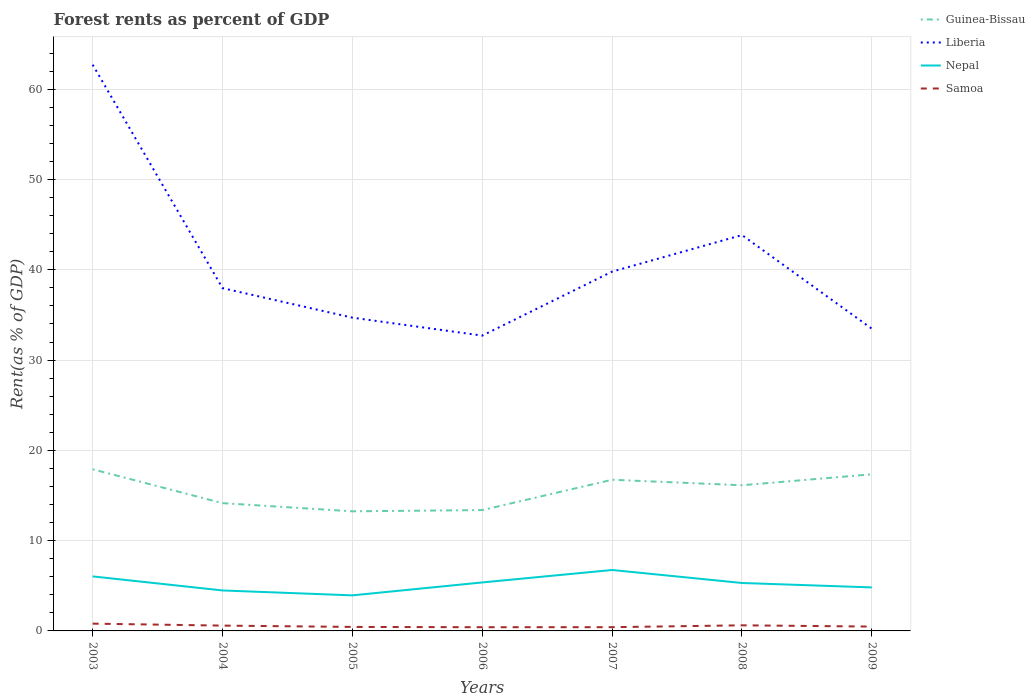Does the line corresponding to Guinea-Bissau intersect with the line corresponding to Liberia?
Provide a short and direct response. No. Is the number of lines equal to the number of legend labels?
Your answer should be very brief. Yes. Across all years, what is the maximum forest rent in Liberia?
Offer a very short reply. 32.71. In which year was the forest rent in Nepal maximum?
Keep it short and to the point. 2005. What is the total forest rent in Liberia in the graph?
Your answer should be very brief. -4.05. What is the difference between the highest and the second highest forest rent in Guinea-Bissau?
Provide a succinct answer. 4.66. What is the difference between the highest and the lowest forest rent in Samoa?
Ensure brevity in your answer.  3. How many lines are there?
Your answer should be compact. 4. How many years are there in the graph?
Your answer should be very brief. 7. Does the graph contain grids?
Provide a succinct answer. Yes. How many legend labels are there?
Provide a succinct answer. 4. How are the legend labels stacked?
Keep it short and to the point. Vertical. What is the title of the graph?
Offer a terse response. Forest rents as percent of GDP. What is the label or title of the X-axis?
Provide a succinct answer. Years. What is the label or title of the Y-axis?
Your answer should be very brief. Rent(as % of GDP). What is the Rent(as % of GDP) in Guinea-Bissau in 2003?
Provide a succinct answer. 17.9. What is the Rent(as % of GDP) of Liberia in 2003?
Provide a succinct answer. 62.72. What is the Rent(as % of GDP) of Nepal in 2003?
Your response must be concise. 6.04. What is the Rent(as % of GDP) in Samoa in 2003?
Keep it short and to the point. 0.81. What is the Rent(as % of GDP) in Guinea-Bissau in 2004?
Offer a terse response. 14.15. What is the Rent(as % of GDP) in Liberia in 2004?
Provide a succinct answer. 37.97. What is the Rent(as % of GDP) of Nepal in 2004?
Provide a short and direct response. 4.48. What is the Rent(as % of GDP) of Samoa in 2004?
Your answer should be very brief. 0.59. What is the Rent(as % of GDP) in Guinea-Bissau in 2005?
Provide a short and direct response. 13.25. What is the Rent(as % of GDP) of Liberia in 2005?
Make the answer very short. 34.7. What is the Rent(as % of GDP) in Nepal in 2005?
Ensure brevity in your answer.  3.94. What is the Rent(as % of GDP) in Samoa in 2005?
Provide a short and direct response. 0.44. What is the Rent(as % of GDP) in Guinea-Bissau in 2006?
Make the answer very short. 13.39. What is the Rent(as % of GDP) of Liberia in 2006?
Your answer should be compact. 32.71. What is the Rent(as % of GDP) of Nepal in 2006?
Give a very brief answer. 5.37. What is the Rent(as % of GDP) of Samoa in 2006?
Offer a very short reply. 0.41. What is the Rent(as % of GDP) of Guinea-Bissau in 2007?
Offer a terse response. 16.74. What is the Rent(as % of GDP) in Liberia in 2007?
Offer a very short reply. 39.8. What is the Rent(as % of GDP) of Nepal in 2007?
Your answer should be very brief. 6.75. What is the Rent(as % of GDP) of Samoa in 2007?
Your response must be concise. 0.41. What is the Rent(as % of GDP) in Guinea-Bissau in 2008?
Provide a succinct answer. 16.13. What is the Rent(as % of GDP) of Liberia in 2008?
Give a very brief answer. 43.85. What is the Rent(as % of GDP) of Nepal in 2008?
Ensure brevity in your answer.  5.31. What is the Rent(as % of GDP) in Samoa in 2008?
Your response must be concise. 0.62. What is the Rent(as % of GDP) of Guinea-Bissau in 2009?
Ensure brevity in your answer.  17.35. What is the Rent(as % of GDP) of Liberia in 2009?
Offer a terse response. 33.48. What is the Rent(as % of GDP) of Nepal in 2009?
Ensure brevity in your answer.  4.82. What is the Rent(as % of GDP) in Samoa in 2009?
Provide a short and direct response. 0.48. Across all years, what is the maximum Rent(as % of GDP) of Guinea-Bissau?
Your answer should be compact. 17.9. Across all years, what is the maximum Rent(as % of GDP) of Liberia?
Ensure brevity in your answer.  62.72. Across all years, what is the maximum Rent(as % of GDP) of Nepal?
Give a very brief answer. 6.75. Across all years, what is the maximum Rent(as % of GDP) in Samoa?
Your response must be concise. 0.81. Across all years, what is the minimum Rent(as % of GDP) of Guinea-Bissau?
Offer a very short reply. 13.25. Across all years, what is the minimum Rent(as % of GDP) of Liberia?
Offer a terse response. 32.71. Across all years, what is the minimum Rent(as % of GDP) in Nepal?
Make the answer very short. 3.94. Across all years, what is the minimum Rent(as % of GDP) in Samoa?
Offer a very short reply. 0.41. What is the total Rent(as % of GDP) in Guinea-Bissau in the graph?
Your answer should be very brief. 108.92. What is the total Rent(as % of GDP) in Liberia in the graph?
Your response must be concise. 285.21. What is the total Rent(as % of GDP) in Nepal in the graph?
Offer a terse response. 36.71. What is the total Rent(as % of GDP) of Samoa in the graph?
Offer a terse response. 3.76. What is the difference between the Rent(as % of GDP) of Guinea-Bissau in 2003 and that in 2004?
Provide a short and direct response. 3.75. What is the difference between the Rent(as % of GDP) of Liberia in 2003 and that in 2004?
Provide a short and direct response. 24.75. What is the difference between the Rent(as % of GDP) of Nepal in 2003 and that in 2004?
Make the answer very short. 1.56. What is the difference between the Rent(as % of GDP) in Samoa in 2003 and that in 2004?
Keep it short and to the point. 0.22. What is the difference between the Rent(as % of GDP) in Guinea-Bissau in 2003 and that in 2005?
Your answer should be very brief. 4.66. What is the difference between the Rent(as % of GDP) of Liberia in 2003 and that in 2005?
Keep it short and to the point. 28.02. What is the difference between the Rent(as % of GDP) in Nepal in 2003 and that in 2005?
Provide a succinct answer. 2.1. What is the difference between the Rent(as % of GDP) in Samoa in 2003 and that in 2005?
Give a very brief answer. 0.36. What is the difference between the Rent(as % of GDP) of Guinea-Bissau in 2003 and that in 2006?
Provide a succinct answer. 4.52. What is the difference between the Rent(as % of GDP) of Liberia in 2003 and that in 2006?
Offer a terse response. 30.01. What is the difference between the Rent(as % of GDP) of Nepal in 2003 and that in 2006?
Give a very brief answer. 0.67. What is the difference between the Rent(as % of GDP) in Samoa in 2003 and that in 2006?
Make the answer very short. 0.4. What is the difference between the Rent(as % of GDP) of Guinea-Bissau in 2003 and that in 2007?
Make the answer very short. 1.16. What is the difference between the Rent(as % of GDP) of Liberia in 2003 and that in 2007?
Ensure brevity in your answer.  22.92. What is the difference between the Rent(as % of GDP) of Nepal in 2003 and that in 2007?
Offer a terse response. -0.71. What is the difference between the Rent(as % of GDP) in Samoa in 2003 and that in 2007?
Give a very brief answer. 0.39. What is the difference between the Rent(as % of GDP) in Guinea-Bissau in 2003 and that in 2008?
Offer a terse response. 1.77. What is the difference between the Rent(as % of GDP) in Liberia in 2003 and that in 2008?
Offer a terse response. 18.87. What is the difference between the Rent(as % of GDP) in Nepal in 2003 and that in 2008?
Give a very brief answer. 0.73. What is the difference between the Rent(as % of GDP) of Samoa in 2003 and that in 2008?
Your answer should be very brief. 0.19. What is the difference between the Rent(as % of GDP) of Guinea-Bissau in 2003 and that in 2009?
Provide a short and direct response. 0.56. What is the difference between the Rent(as % of GDP) of Liberia in 2003 and that in 2009?
Offer a terse response. 29.24. What is the difference between the Rent(as % of GDP) of Nepal in 2003 and that in 2009?
Your response must be concise. 1.22. What is the difference between the Rent(as % of GDP) in Samoa in 2003 and that in 2009?
Keep it short and to the point. 0.33. What is the difference between the Rent(as % of GDP) in Guinea-Bissau in 2004 and that in 2005?
Offer a very short reply. 0.9. What is the difference between the Rent(as % of GDP) in Liberia in 2004 and that in 2005?
Provide a short and direct response. 3.27. What is the difference between the Rent(as % of GDP) in Nepal in 2004 and that in 2005?
Provide a short and direct response. 0.54. What is the difference between the Rent(as % of GDP) of Samoa in 2004 and that in 2005?
Offer a very short reply. 0.15. What is the difference between the Rent(as % of GDP) in Guinea-Bissau in 2004 and that in 2006?
Offer a terse response. 0.77. What is the difference between the Rent(as % of GDP) of Liberia in 2004 and that in 2006?
Your response must be concise. 5.26. What is the difference between the Rent(as % of GDP) of Nepal in 2004 and that in 2006?
Keep it short and to the point. -0.89. What is the difference between the Rent(as % of GDP) in Samoa in 2004 and that in 2006?
Offer a very short reply. 0.18. What is the difference between the Rent(as % of GDP) in Guinea-Bissau in 2004 and that in 2007?
Your answer should be very brief. -2.59. What is the difference between the Rent(as % of GDP) of Liberia in 2004 and that in 2007?
Provide a succinct answer. -1.83. What is the difference between the Rent(as % of GDP) in Nepal in 2004 and that in 2007?
Ensure brevity in your answer.  -2.27. What is the difference between the Rent(as % of GDP) of Samoa in 2004 and that in 2007?
Provide a succinct answer. 0.17. What is the difference between the Rent(as % of GDP) in Guinea-Bissau in 2004 and that in 2008?
Your answer should be compact. -1.98. What is the difference between the Rent(as % of GDP) of Liberia in 2004 and that in 2008?
Ensure brevity in your answer.  -5.88. What is the difference between the Rent(as % of GDP) of Nepal in 2004 and that in 2008?
Your answer should be very brief. -0.83. What is the difference between the Rent(as % of GDP) in Samoa in 2004 and that in 2008?
Give a very brief answer. -0.03. What is the difference between the Rent(as % of GDP) in Guinea-Bissau in 2004 and that in 2009?
Keep it short and to the point. -3.2. What is the difference between the Rent(as % of GDP) of Liberia in 2004 and that in 2009?
Offer a terse response. 4.49. What is the difference between the Rent(as % of GDP) in Nepal in 2004 and that in 2009?
Ensure brevity in your answer.  -0.34. What is the difference between the Rent(as % of GDP) of Samoa in 2004 and that in 2009?
Give a very brief answer. 0.11. What is the difference between the Rent(as % of GDP) of Guinea-Bissau in 2005 and that in 2006?
Offer a terse response. -0.14. What is the difference between the Rent(as % of GDP) in Liberia in 2005 and that in 2006?
Your response must be concise. 1.99. What is the difference between the Rent(as % of GDP) of Nepal in 2005 and that in 2006?
Provide a short and direct response. -1.43. What is the difference between the Rent(as % of GDP) in Samoa in 2005 and that in 2006?
Make the answer very short. 0.03. What is the difference between the Rent(as % of GDP) of Guinea-Bissau in 2005 and that in 2007?
Your answer should be compact. -3.5. What is the difference between the Rent(as % of GDP) in Liberia in 2005 and that in 2007?
Your answer should be very brief. -5.1. What is the difference between the Rent(as % of GDP) in Nepal in 2005 and that in 2007?
Provide a short and direct response. -2.81. What is the difference between the Rent(as % of GDP) of Samoa in 2005 and that in 2007?
Your answer should be very brief. 0.03. What is the difference between the Rent(as % of GDP) in Guinea-Bissau in 2005 and that in 2008?
Ensure brevity in your answer.  -2.89. What is the difference between the Rent(as % of GDP) in Liberia in 2005 and that in 2008?
Give a very brief answer. -9.15. What is the difference between the Rent(as % of GDP) of Nepal in 2005 and that in 2008?
Your response must be concise. -1.37. What is the difference between the Rent(as % of GDP) in Samoa in 2005 and that in 2008?
Ensure brevity in your answer.  -0.18. What is the difference between the Rent(as % of GDP) of Guinea-Bissau in 2005 and that in 2009?
Provide a short and direct response. -4.1. What is the difference between the Rent(as % of GDP) in Liberia in 2005 and that in 2009?
Make the answer very short. 1.22. What is the difference between the Rent(as % of GDP) of Nepal in 2005 and that in 2009?
Offer a terse response. -0.88. What is the difference between the Rent(as % of GDP) of Samoa in 2005 and that in 2009?
Give a very brief answer. -0.04. What is the difference between the Rent(as % of GDP) in Guinea-Bissau in 2006 and that in 2007?
Make the answer very short. -3.36. What is the difference between the Rent(as % of GDP) in Liberia in 2006 and that in 2007?
Ensure brevity in your answer.  -7.09. What is the difference between the Rent(as % of GDP) of Nepal in 2006 and that in 2007?
Keep it short and to the point. -1.38. What is the difference between the Rent(as % of GDP) of Samoa in 2006 and that in 2007?
Give a very brief answer. -0. What is the difference between the Rent(as % of GDP) of Guinea-Bissau in 2006 and that in 2008?
Keep it short and to the point. -2.75. What is the difference between the Rent(as % of GDP) in Liberia in 2006 and that in 2008?
Your answer should be compact. -11.14. What is the difference between the Rent(as % of GDP) of Nepal in 2006 and that in 2008?
Offer a terse response. 0.06. What is the difference between the Rent(as % of GDP) in Samoa in 2006 and that in 2008?
Make the answer very short. -0.21. What is the difference between the Rent(as % of GDP) in Guinea-Bissau in 2006 and that in 2009?
Keep it short and to the point. -3.96. What is the difference between the Rent(as % of GDP) in Liberia in 2006 and that in 2009?
Your answer should be very brief. -0.77. What is the difference between the Rent(as % of GDP) of Nepal in 2006 and that in 2009?
Give a very brief answer. 0.55. What is the difference between the Rent(as % of GDP) in Samoa in 2006 and that in 2009?
Provide a short and direct response. -0.07. What is the difference between the Rent(as % of GDP) in Guinea-Bissau in 2007 and that in 2008?
Keep it short and to the point. 0.61. What is the difference between the Rent(as % of GDP) in Liberia in 2007 and that in 2008?
Make the answer very short. -4.05. What is the difference between the Rent(as % of GDP) in Nepal in 2007 and that in 2008?
Give a very brief answer. 1.44. What is the difference between the Rent(as % of GDP) in Samoa in 2007 and that in 2008?
Make the answer very short. -0.21. What is the difference between the Rent(as % of GDP) of Guinea-Bissau in 2007 and that in 2009?
Your answer should be very brief. -0.6. What is the difference between the Rent(as % of GDP) in Liberia in 2007 and that in 2009?
Offer a terse response. 6.32. What is the difference between the Rent(as % of GDP) of Nepal in 2007 and that in 2009?
Offer a terse response. 1.93. What is the difference between the Rent(as % of GDP) of Samoa in 2007 and that in 2009?
Provide a succinct answer. -0.07. What is the difference between the Rent(as % of GDP) in Guinea-Bissau in 2008 and that in 2009?
Offer a terse response. -1.21. What is the difference between the Rent(as % of GDP) in Liberia in 2008 and that in 2009?
Your response must be concise. 10.37. What is the difference between the Rent(as % of GDP) of Nepal in 2008 and that in 2009?
Keep it short and to the point. 0.49. What is the difference between the Rent(as % of GDP) of Samoa in 2008 and that in 2009?
Offer a terse response. 0.14. What is the difference between the Rent(as % of GDP) in Guinea-Bissau in 2003 and the Rent(as % of GDP) in Liberia in 2004?
Offer a terse response. -20.06. What is the difference between the Rent(as % of GDP) in Guinea-Bissau in 2003 and the Rent(as % of GDP) in Nepal in 2004?
Make the answer very short. 13.42. What is the difference between the Rent(as % of GDP) in Guinea-Bissau in 2003 and the Rent(as % of GDP) in Samoa in 2004?
Offer a very short reply. 17.32. What is the difference between the Rent(as % of GDP) of Liberia in 2003 and the Rent(as % of GDP) of Nepal in 2004?
Your answer should be compact. 58.23. What is the difference between the Rent(as % of GDP) of Liberia in 2003 and the Rent(as % of GDP) of Samoa in 2004?
Make the answer very short. 62.13. What is the difference between the Rent(as % of GDP) in Nepal in 2003 and the Rent(as % of GDP) in Samoa in 2004?
Offer a very short reply. 5.45. What is the difference between the Rent(as % of GDP) in Guinea-Bissau in 2003 and the Rent(as % of GDP) in Liberia in 2005?
Provide a succinct answer. -16.8. What is the difference between the Rent(as % of GDP) in Guinea-Bissau in 2003 and the Rent(as % of GDP) in Nepal in 2005?
Provide a succinct answer. 13.97. What is the difference between the Rent(as % of GDP) in Guinea-Bissau in 2003 and the Rent(as % of GDP) in Samoa in 2005?
Your answer should be compact. 17.46. What is the difference between the Rent(as % of GDP) in Liberia in 2003 and the Rent(as % of GDP) in Nepal in 2005?
Give a very brief answer. 58.78. What is the difference between the Rent(as % of GDP) of Liberia in 2003 and the Rent(as % of GDP) of Samoa in 2005?
Provide a succinct answer. 62.28. What is the difference between the Rent(as % of GDP) in Nepal in 2003 and the Rent(as % of GDP) in Samoa in 2005?
Your answer should be compact. 5.6. What is the difference between the Rent(as % of GDP) of Guinea-Bissau in 2003 and the Rent(as % of GDP) of Liberia in 2006?
Make the answer very short. -14.81. What is the difference between the Rent(as % of GDP) of Guinea-Bissau in 2003 and the Rent(as % of GDP) of Nepal in 2006?
Provide a succinct answer. 12.53. What is the difference between the Rent(as % of GDP) of Guinea-Bissau in 2003 and the Rent(as % of GDP) of Samoa in 2006?
Give a very brief answer. 17.49. What is the difference between the Rent(as % of GDP) of Liberia in 2003 and the Rent(as % of GDP) of Nepal in 2006?
Offer a very short reply. 57.35. What is the difference between the Rent(as % of GDP) of Liberia in 2003 and the Rent(as % of GDP) of Samoa in 2006?
Your answer should be very brief. 62.31. What is the difference between the Rent(as % of GDP) in Nepal in 2003 and the Rent(as % of GDP) in Samoa in 2006?
Ensure brevity in your answer.  5.63. What is the difference between the Rent(as % of GDP) in Guinea-Bissau in 2003 and the Rent(as % of GDP) in Liberia in 2007?
Give a very brief answer. -21.89. What is the difference between the Rent(as % of GDP) of Guinea-Bissau in 2003 and the Rent(as % of GDP) of Nepal in 2007?
Provide a succinct answer. 11.16. What is the difference between the Rent(as % of GDP) of Guinea-Bissau in 2003 and the Rent(as % of GDP) of Samoa in 2007?
Offer a terse response. 17.49. What is the difference between the Rent(as % of GDP) in Liberia in 2003 and the Rent(as % of GDP) in Nepal in 2007?
Offer a terse response. 55.97. What is the difference between the Rent(as % of GDP) in Liberia in 2003 and the Rent(as % of GDP) in Samoa in 2007?
Give a very brief answer. 62.3. What is the difference between the Rent(as % of GDP) of Nepal in 2003 and the Rent(as % of GDP) of Samoa in 2007?
Offer a very short reply. 5.62. What is the difference between the Rent(as % of GDP) in Guinea-Bissau in 2003 and the Rent(as % of GDP) in Liberia in 2008?
Provide a short and direct response. -25.94. What is the difference between the Rent(as % of GDP) in Guinea-Bissau in 2003 and the Rent(as % of GDP) in Nepal in 2008?
Your answer should be compact. 12.59. What is the difference between the Rent(as % of GDP) of Guinea-Bissau in 2003 and the Rent(as % of GDP) of Samoa in 2008?
Provide a short and direct response. 17.28. What is the difference between the Rent(as % of GDP) of Liberia in 2003 and the Rent(as % of GDP) of Nepal in 2008?
Your answer should be very brief. 57.41. What is the difference between the Rent(as % of GDP) in Liberia in 2003 and the Rent(as % of GDP) in Samoa in 2008?
Keep it short and to the point. 62.1. What is the difference between the Rent(as % of GDP) of Nepal in 2003 and the Rent(as % of GDP) of Samoa in 2008?
Your answer should be compact. 5.42. What is the difference between the Rent(as % of GDP) of Guinea-Bissau in 2003 and the Rent(as % of GDP) of Liberia in 2009?
Ensure brevity in your answer.  -15.57. What is the difference between the Rent(as % of GDP) of Guinea-Bissau in 2003 and the Rent(as % of GDP) of Nepal in 2009?
Give a very brief answer. 13.08. What is the difference between the Rent(as % of GDP) of Guinea-Bissau in 2003 and the Rent(as % of GDP) of Samoa in 2009?
Your response must be concise. 17.42. What is the difference between the Rent(as % of GDP) of Liberia in 2003 and the Rent(as % of GDP) of Nepal in 2009?
Your answer should be very brief. 57.9. What is the difference between the Rent(as % of GDP) of Liberia in 2003 and the Rent(as % of GDP) of Samoa in 2009?
Your answer should be very brief. 62.24. What is the difference between the Rent(as % of GDP) of Nepal in 2003 and the Rent(as % of GDP) of Samoa in 2009?
Provide a succinct answer. 5.56. What is the difference between the Rent(as % of GDP) of Guinea-Bissau in 2004 and the Rent(as % of GDP) of Liberia in 2005?
Your answer should be very brief. -20.55. What is the difference between the Rent(as % of GDP) of Guinea-Bissau in 2004 and the Rent(as % of GDP) of Nepal in 2005?
Your answer should be compact. 10.21. What is the difference between the Rent(as % of GDP) in Guinea-Bissau in 2004 and the Rent(as % of GDP) in Samoa in 2005?
Ensure brevity in your answer.  13.71. What is the difference between the Rent(as % of GDP) in Liberia in 2004 and the Rent(as % of GDP) in Nepal in 2005?
Ensure brevity in your answer.  34.03. What is the difference between the Rent(as % of GDP) of Liberia in 2004 and the Rent(as % of GDP) of Samoa in 2005?
Ensure brevity in your answer.  37.52. What is the difference between the Rent(as % of GDP) in Nepal in 2004 and the Rent(as % of GDP) in Samoa in 2005?
Provide a succinct answer. 4.04. What is the difference between the Rent(as % of GDP) in Guinea-Bissau in 2004 and the Rent(as % of GDP) in Liberia in 2006?
Give a very brief answer. -18.56. What is the difference between the Rent(as % of GDP) in Guinea-Bissau in 2004 and the Rent(as % of GDP) in Nepal in 2006?
Offer a terse response. 8.78. What is the difference between the Rent(as % of GDP) of Guinea-Bissau in 2004 and the Rent(as % of GDP) of Samoa in 2006?
Provide a short and direct response. 13.74. What is the difference between the Rent(as % of GDP) in Liberia in 2004 and the Rent(as % of GDP) in Nepal in 2006?
Give a very brief answer. 32.6. What is the difference between the Rent(as % of GDP) in Liberia in 2004 and the Rent(as % of GDP) in Samoa in 2006?
Ensure brevity in your answer.  37.56. What is the difference between the Rent(as % of GDP) in Nepal in 2004 and the Rent(as % of GDP) in Samoa in 2006?
Keep it short and to the point. 4.07. What is the difference between the Rent(as % of GDP) of Guinea-Bissau in 2004 and the Rent(as % of GDP) of Liberia in 2007?
Offer a terse response. -25.65. What is the difference between the Rent(as % of GDP) of Guinea-Bissau in 2004 and the Rent(as % of GDP) of Nepal in 2007?
Your response must be concise. 7.4. What is the difference between the Rent(as % of GDP) of Guinea-Bissau in 2004 and the Rent(as % of GDP) of Samoa in 2007?
Your answer should be very brief. 13.74. What is the difference between the Rent(as % of GDP) in Liberia in 2004 and the Rent(as % of GDP) in Nepal in 2007?
Your answer should be very brief. 31.22. What is the difference between the Rent(as % of GDP) of Liberia in 2004 and the Rent(as % of GDP) of Samoa in 2007?
Offer a very short reply. 37.55. What is the difference between the Rent(as % of GDP) in Nepal in 2004 and the Rent(as % of GDP) in Samoa in 2007?
Your answer should be compact. 4.07. What is the difference between the Rent(as % of GDP) of Guinea-Bissau in 2004 and the Rent(as % of GDP) of Liberia in 2008?
Your answer should be very brief. -29.69. What is the difference between the Rent(as % of GDP) of Guinea-Bissau in 2004 and the Rent(as % of GDP) of Nepal in 2008?
Give a very brief answer. 8.84. What is the difference between the Rent(as % of GDP) in Guinea-Bissau in 2004 and the Rent(as % of GDP) in Samoa in 2008?
Your answer should be compact. 13.53. What is the difference between the Rent(as % of GDP) of Liberia in 2004 and the Rent(as % of GDP) of Nepal in 2008?
Your answer should be very brief. 32.66. What is the difference between the Rent(as % of GDP) in Liberia in 2004 and the Rent(as % of GDP) in Samoa in 2008?
Give a very brief answer. 37.35. What is the difference between the Rent(as % of GDP) of Nepal in 2004 and the Rent(as % of GDP) of Samoa in 2008?
Ensure brevity in your answer.  3.86. What is the difference between the Rent(as % of GDP) of Guinea-Bissau in 2004 and the Rent(as % of GDP) of Liberia in 2009?
Give a very brief answer. -19.32. What is the difference between the Rent(as % of GDP) in Guinea-Bissau in 2004 and the Rent(as % of GDP) in Nepal in 2009?
Offer a terse response. 9.33. What is the difference between the Rent(as % of GDP) in Guinea-Bissau in 2004 and the Rent(as % of GDP) in Samoa in 2009?
Offer a terse response. 13.67. What is the difference between the Rent(as % of GDP) in Liberia in 2004 and the Rent(as % of GDP) in Nepal in 2009?
Offer a very short reply. 33.15. What is the difference between the Rent(as % of GDP) in Liberia in 2004 and the Rent(as % of GDP) in Samoa in 2009?
Provide a succinct answer. 37.49. What is the difference between the Rent(as % of GDP) of Nepal in 2004 and the Rent(as % of GDP) of Samoa in 2009?
Offer a terse response. 4. What is the difference between the Rent(as % of GDP) in Guinea-Bissau in 2005 and the Rent(as % of GDP) in Liberia in 2006?
Your answer should be compact. -19.46. What is the difference between the Rent(as % of GDP) of Guinea-Bissau in 2005 and the Rent(as % of GDP) of Nepal in 2006?
Make the answer very short. 7.88. What is the difference between the Rent(as % of GDP) in Guinea-Bissau in 2005 and the Rent(as % of GDP) in Samoa in 2006?
Ensure brevity in your answer.  12.84. What is the difference between the Rent(as % of GDP) of Liberia in 2005 and the Rent(as % of GDP) of Nepal in 2006?
Your response must be concise. 29.33. What is the difference between the Rent(as % of GDP) of Liberia in 2005 and the Rent(as % of GDP) of Samoa in 2006?
Ensure brevity in your answer.  34.29. What is the difference between the Rent(as % of GDP) in Nepal in 2005 and the Rent(as % of GDP) in Samoa in 2006?
Make the answer very short. 3.53. What is the difference between the Rent(as % of GDP) of Guinea-Bissau in 2005 and the Rent(as % of GDP) of Liberia in 2007?
Provide a succinct answer. -26.55. What is the difference between the Rent(as % of GDP) of Guinea-Bissau in 2005 and the Rent(as % of GDP) of Nepal in 2007?
Give a very brief answer. 6.5. What is the difference between the Rent(as % of GDP) of Guinea-Bissau in 2005 and the Rent(as % of GDP) of Samoa in 2007?
Offer a terse response. 12.83. What is the difference between the Rent(as % of GDP) of Liberia in 2005 and the Rent(as % of GDP) of Nepal in 2007?
Keep it short and to the point. 27.95. What is the difference between the Rent(as % of GDP) in Liberia in 2005 and the Rent(as % of GDP) in Samoa in 2007?
Give a very brief answer. 34.28. What is the difference between the Rent(as % of GDP) in Nepal in 2005 and the Rent(as % of GDP) in Samoa in 2007?
Offer a terse response. 3.52. What is the difference between the Rent(as % of GDP) of Guinea-Bissau in 2005 and the Rent(as % of GDP) of Liberia in 2008?
Provide a succinct answer. -30.6. What is the difference between the Rent(as % of GDP) in Guinea-Bissau in 2005 and the Rent(as % of GDP) in Nepal in 2008?
Give a very brief answer. 7.94. What is the difference between the Rent(as % of GDP) of Guinea-Bissau in 2005 and the Rent(as % of GDP) of Samoa in 2008?
Your answer should be very brief. 12.63. What is the difference between the Rent(as % of GDP) of Liberia in 2005 and the Rent(as % of GDP) of Nepal in 2008?
Make the answer very short. 29.39. What is the difference between the Rent(as % of GDP) of Liberia in 2005 and the Rent(as % of GDP) of Samoa in 2008?
Your response must be concise. 34.08. What is the difference between the Rent(as % of GDP) of Nepal in 2005 and the Rent(as % of GDP) of Samoa in 2008?
Your answer should be very brief. 3.32. What is the difference between the Rent(as % of GDP) of Guinea-Bissau in 2005 and the Rent(as % of GDP) of Liberia in 2009?
Your answer should be compact. -20.23. What is the difference between the Rent(as % of GDP) of Guinea-Bissau in 2005 and the Rent(as % of GDP) of Nepal in 2009?
Keep it short and to the point. 8.43. What is the difference between the Rent(as % of GDP) of Guinea-Bissau in 2005 and the Rent(as % of GDP) of Samoa in 2009?
Give a very brief answer. 12.77. What is the difference between the Rent(as % of GDP) of Liberia in 2005 and the Rent(as % of GDP) of Nepal in 2009?
Provide a succinct answer. 29.88. What is the difference between the Rent(as % of GDP) of Liberia in 2005 and the Rent(as % of GDP) of Samoa in 2009?
Your answer should be compact. 34.22. What is the difference between the Rent(as % of GDP) of Nepal in 2005 and the Rent(as % of GDP) of Samoa in 2009?
Ensure brevity in your answer.  3.46. What is the difference between the Rent(as % of GDP) in Guinea-Bissau in 2006 and the Rent(as % of GDP) in Liberia in 2007?
Offer a very short reply. -26.41. What is the difference between the Rent(as % of GDP) of Guinea-Bissau in 2006 and the Rent(as % of GDP) of Nepal in 2007?
Give a very brief answer. 6.64. What is the difference between the Rent(as % of GDP) in Guinea-Bissau in 2006 and the Rent(as % of GDP) in Samoa in 2007?
Offer a very short reply. 12.97. What is the difference between the Rent(as % of GDP) in Liberia in 2006 and the Rent(as % of GDP) in Nepal in 2007?
Offer a very short reply. 25.96. What is the difference between the Rent(as % of GDP) of Liberia in 2006 and the Rent(as % of GDP) of Samoa in 2007?
Give a very brief answer. 32.3. What is the difference between the Rent(as % of GDP) of Nepal in 2006 and the Rent(as % of GDP) of Samoa in 2007?
Your answer should be very brief. 4.96. What is the difference between the Rent(as % of GDP) in Guinea-Bissau in 2006 and the Rent(as % of GDP) in Liberia in 2008?
Provide a short and direct response. -30.46. What is the difference between the Rent(as % of GDP) in Guinea-Bissau in 2006 and the Rent(as % of GDP) in Nepal in 2008?
Keep it short and to the point. 8.08. What is the difference between the Rent(as % of GDP) in Guinea-Bissau in 2006 and the Rent(as % of GDP) in Samoa in 2008?
Your response must be concise. 12.77. What is the difference between the Rent(as % of GDP) of Liberia in 2006 and the Rent(as % of GDP) of Nepal in 2008?
Give a very brief answer. 27.4. What is the difference between the Rent(as % of GDP) in Liberia in 2006 and the Rent(as % of GDP) in Samoa in 2008?
Offer a terse response. 32.09. What is the difference between the Rent(as % of GDP) in Nepal in 2006 and the Rent(as % of GDP) in Samoa in 2008?
Ensure brevity in your answer.  4.75. What is the difference between the Rent(as % of GDP) in Guinea-Bissau in 2006 and the Rent(as % of GDP) in Liberia in 2009?
Give a very brief answer. -20.09. What is the difference between the Rent(as % of GDP) in Guinea-Bissau in 2006 and the Rent(as % of GDP) in Nepal in 2009?
Offer a very short reply. 8.56. What is the difference between the Rent(as % of GDP) in Guinea-Bissau in 2006 and the Rent(as % of GDP) in Samoa in 2009?
Provide a short and direct response. 12.9. What is the difference between the Rent(as % of GDP) of Liberia in 2006 and the Rent(as % of GDP) of Nepal in 2009?
Keep it short and to the point. 27.89. What is the difference between the Rent(as % of GDP) in Liberia in 2006 and the Rent(as % of GDP) in Samoa in 2009?
Give a very brief answer. 32.23. What is the difference between the Rent(as % of GDP) in Nepal in 2006 and the Rent(as % of GDP) in Samoa in 2009?
Offer a very short reply. 4.89. What is the difference between the Rent(as % of GDP) in Guinea-Bissau in 2007 and the Rent(as % of GDP) in Liberia in 2008?
Your response must be concise. -27.1. What is the difference between the Rent(as % of GDP) in Guinea-Bissau in 2007 and the Rent(as % of GDP) in Nepal in 2008?
Ensure brevity in your answer.  11.43. What is the difference between the Rent(as % of GDP) of Guinea-Bissau in 2007 and the Rent(as % of GDP) of Samoa in 2008?
Offer a very short reply. 16.12. What is the difference between the Rent(as % of GDP) in Liberia in 2007 and the Rent(as % of GDP) in Nepal in 2008?
Your answer should be very brief. 34.49. What is the difference between the Rent(as % of GDP) in Liberia in 2007 and the Rent(as % of GDP) in Samoa in 2008?
Keep it short and to the point. 39.18. What is the difference between the Rent(as % of GDP) in Nepal in 2007 and the Rent(as % of GDP) in Samoa in 2008?
Offer a terse response. 6.13. What is the difference between the Rent(as % of GDP) in Guinea-Bissau in 2007 and the Rent(as % of GDP) in Liberia in 2009?
Keep it short and to the point. -16.73. What is the difference between the Rent(as % of GDP) in Guinea-Bissau in 2007 and the Rent(as % of GDP) in Nepal in 2009?
Keep it short and to the point. 11.92. What is the difference between the Rent(as % of GDP) in Guinea-Bissau in 2007 and the Rent(as % of GDP) in Samoa in 2009?
Offer a terse response. 16.26. What is the difference between the Rent(as % of GDP) of Liberia in 2007 and the Rent(as % of GDP) of Nepal in 2009?
Offer a very short reply. 34.98. What is the difference between the Rent(as % of GDP) of Liberia in 2007 and the Rent(as % of GDP) of Samoa in 2009?
Offer a very short reply. 39.32. What is the difference between the Rent(as % of GDP) of Nepal in 2007 and the Rent(as % of GDP) of Samoa in 2009?
Provide a short and direct response. 6.27. What is the difference between the Rent(as % of GDP) in Guinea-Bissau in 2008 and the Rent(as % of GDP) in Liberia in 2009?
Your response must be concise. -17.34. What is the difference between the Rent(as % of GDP) of Guinea-Bissau in 2008 and the Rent(as % of GDP) of Nepal in 2009?
Your answer should be compact. 11.31. What is the difference between the Rent(as % of GDP) in Guinea-Bissau in 2008 and the Rent(as % of GDP) in Samoa in 2009?
Your answer should be compact. 15.65. What is the difference between the Rent(as % of GDP) in Liberia in 2008 and the Rent(as % of GDP) in Nepal in 2009?
Provide a succinct answer. 39.03. What is the difference between the Rent(as % of GDP) in Liberia in 2008 and the Rent(as % of GDP) in Samoa in 2009?
Offer a very short reply. 43.37. What is the difference between the Rent(as % of GDP) in Nepal in 2008 and the Rent(as % of GDP) in Samoa in 2009?
Your answer should be compact. 4.83. What is the average Rent(as % of GDP) in Guinea-Bissau per year?
Ensure brevity in your answer.  15.56. What is the average Rent(as % of GDP) of Liberia per year?
Make the answer very short. 40.74. What is the average Rent(as % of GDP) of Nepal per year?
Your answer should be very brief. 5.24. What is the average Rent(as % of GDP) of Samoa per year?
Make the answer very short. 0.54. In the year 2003, what is the difference between the Rent(as % of GDP) of Guinea-Bissau and Rent(as % of GDP) of Liberia?
Give a very brief answer. -44.81. In the year 2003, what is the difference between the Rent(as % of GDP) of Guinea-Bissau and Rent(as % of GDP) of Nepal?
Ensure brevity in your answer.  11.87. In the year 2003, what is the difference between the Rent(as % of GDP) of Guinea-Bissau and Rent(as % of GDP) of Samoa?
Give a very brief answer. 17.1. In the year 2003, what is the difference between the Rent(as % of GDP) in Liberia and Rent(as % of GDP) in Nepal?
Make the answer very short. 56.68. In the year 2003, what is the difference between the Rent(as % of GDP) of Liberia and Rent(as % of GDP) of Samoa?
Your answer should be compact. 61.91. In the year 2003, what is the difference between the Rent(as % of GDP) in Nepal and Rent(as % of GDP) in Samoa?
Your response must be concise. 5.23. In the year 2004, what is the difference between the Rent(as % of GDP) in Guinea-Bissau and Rent(as % of GDP) in Liberia?
Ensure brevity in your answer.  -23.81. In the year 2004, what is the difference between the Rent(as % of GDP) of Guinea-Bissau and Rent(as % of GDP) of Nepal?
Give a very brief answer. 9.67. In the year 2004, what is the difference between the Rent(as % of GDP) of Guinea-Bissau and Rent(as % of GDP) of Samoa?
Ensure brevity in your answer.  13.56. In the year 2004, what is the difference between the Rent(as % of GDP) in Liberia and Rent(as % of GDP) in Nepal?
Ensure brevity in your answer.  33.48. In the year 2004, what is the difference between the Rent(as % of GDP) in Liberia and Rent(as % of GDP) in Samoa?
Provide a succinct answer. 37.38. In the year 2004, what is the difference between the Rent(as % of GDP) of Nepal and Rent(as % of GDP) of Samoa?
Give a very brief answer. 3.89. In the year 2005, what is the difference between the Rent(as % of GDP) in Guinea-Bissau and Rent(as % of GDP) in Liberia?
Your answer should be compact. -21.45. In the year 2005, what is the difference between the Rent(as % of GDP) of Guinea-Bissau and Rent(as % of GDP) of Nepal?
Offer a very short reply. 9.31. In the year 2005, what is the difference between the Rent(as % of GDP) in Guinea-Bissau and Rent(as % of GDP) in Samoa?
Keep it short and to the point. 12.81. In the year 2005, what is the difference between the Rent(as % of GDP) in Liberia and Rent(as % of GDP) in Nepal?
Give a very brief answer. 30.76. In the year 2005, what is the difference between the Rent(as % of GDP) in Liberia and Rent(as % of GDP) in Samoa?
Keep it short and to the point. 34.26. In the year 2005, what is the difference between the Rent(as % of GDP) of Nepal and Rent(as % of GDP) of Samoa?
Ensure brevity in your answer.  3.5. In the year 2006, what is the difference between the Rent(as % of GDP) in Guinea-Bissau and Rent(as % of GDP) in Liberia?
Provide a succinct answer. -19.32. In the year 2006, what is the difference between the Rent(as % of GDP) of Guinea-Bissau and Rent(as % of GDP) of Nepal?
Your answer should be very brief. 8.02. In the year 2006, what is the difference between the Rent(as % of GDP) in Guinea-Bissau and Rent(as % of GDP) in Samoa?
Make the answer very short. 12.98. In the year 2006, what is the difference between the Rent(as % of GDP) of Liberia and Rent(as % of GDP) of Nepal?
Your response must be concise. 27.34. In the year 2006, what is the difference between the Rent(as % of GDP) of Liberia and Rent(as % of GDP) of Samoa?
Keep it short and to the point. 32.3. In the year 2006, what is the difference between the Rent(as % of GDP) in Nepal and Rent(as % of GDP) in Samoa?
Make the answer very short. 4.96. In the year 2007, what is the difference between the Rent(as % of GDP) in Guinea-Bissau and Rent(as % of GDP) in Liberia?
Give a very brief answer. -23.05. In the year 2007, what is the difference between the Rent(as % of GDP) in Guinea-Bissau and Rent(as % of GDP) in Nepal?
Your response must be concise. 10. In the year 2007, what is the difference between the Rent(as % of GDP) of Guinea-Bissau and Rent(as % of GDP) of Samoa?
Offer a very short reply. 16.33. In the year 2007, what is the difference between the Rent(as % of GDP) of Liberia and Rent(as % of GDP) of Nepal?
Your answer should be very brief. 33.05. In the year 2007, what is the difference between the Rent(as % of GDP) of Liberia and Rent(as % of GDP) of Samoa?
Provide a short and direct response. 39.38. In the year 2007, what is the difference between the Rent(as % of GDP) in Nepal and Rent(as % of GDP) in Samoa?
Provide a succinct answer. 6.33. In the year 2008, what is the difference between the Rent(as % of GDP) in Guinea-Bissau and Rent(as % of GDP) in Liberia?
Your response must be concise. -27.71. In the year 2008, what is the difference between the Rent(as % of GDP) of Guinea-Bissau and Rent(as % of GDP) of Nepal?
Your answer should be compact. 10.82. In the year 2008, what is the difference between the Rent(as % of GDP) in Guinea-Bissau and Rent(as % of GDP) in Samoa?
Provide a succinct answer. 15.51. In the year 2008, what is the difference between the Rent(as % of GDP) in Liberia and Rent(as % of GDP) in Nepal?
Offer a very short reply. 38.54. In the year 2008, what is the difference between the Rent(as % of GDP) in Liberia and Rent(as % of GDP) in Samoa?
Ensure brevity in your answer.  43.23. In the year 2008, what is the difference between the Rent(as % of GDP) in Nepal and Rent(as % of GDP) in Samoa?
Provide a succinct answer. 4.69. In the year 2009, what is the difference between the Rent(as % of GDP) in Guinea-Bissau and Rent(as % of GDP) in Liberia?
Ensure brevity in your answer.  -16.13. In the year 2009, what is the difference between the Rent(as % of GDP) of Guinea-Bissau and Rent(as % of GDP) of Nepal?
Your response must be concise. 12.53. In the year 2009, what is the difference between the Rent(as % of GDP) in Guinea-Bissau and Rent(as % of GDP) in Samoa?
Provide a short and direct response. 16.87. In the year 2009, what is the difference between the Rent(as % of GDP) in Liberia and Rent(as % of GDP) in Nepal?
Offer a terse response. 28.65. In the year 2009, what is the difference between the Rent(as % of GDP) of Liberia and Rent(as % of GDP) of Samoa?
Provide a succinct answer. 32.99. In the year 2009, what is the difference between the Rent(as % of GDP) in Nepal and Rent(as % of GDP) in Samoa?
Ensure brevity in your answer.  4.34. What is the ratio of the Rent(as % of GDP) of Guinea-Bissau in 2003 to that in 2004?
Make the answer very short. 1.27. What is the ratio of the Rent(as % of GDP) in Liberia in 2003 to that in 2004?
Provide a short and direct response. 1.65. What is the ratio of the Rent(as % of GDP) in Nepal in 2003 to that in 2004?
Your answer should be very brief. 1.35. What is the ratio of the Rent(as % of GDP) of Samoa in 2003 to that in 2004?
Offer a very short reply. 1.37. What is the ratio of the Rent(as % of GDP) in Guinea-Bissau in 2003 to that in 2005?
Make the answer very short. 1.35. What is the ratio of the Rent(as % of GDP) in Liberia in 2003 to that in 2005?
Ensure brevity in your answer.  1.81. What is the ratio of the Rent(as % of GDP) of Nepal in 2003 to that in 2005?
Your answer should be very brief. 1.53. What is the ratio of the Rent(as % of GDP) in Samoa in 2003 to that in 2005?
Give a very brief answer. 1.82. What is the ratio of the Rent(as % of GDP) in Guinea-Bissau in 2003 to that in 2006?
Provide a short and direct response. 1.34. What is the ratio of the Rent(as % of GDP) in Liberia in 2003 to that in 2006?
Ensure brevity in your answer.  1.92. What is the ratio of the Rent(as % of GDP) in Nepal in 2003 to that in 2006?
Ensure brevity in your answer.  1.12. What is the ratio of the Rent(as % of GDP) of Samoa in 2003 to that in 2006?
Give a very brief answer. 1.97. What is the ratio of the Rent(as % of GDP) of Guinea-Bissau in 2003 to that in 2007?
Ensure brevity in your answer.  1.07. What is the ratio of the Rent(as % of GDP) in Liberia in 2003 to that in 2007?
Make the answer very short. 1.58. What is the ratio of the Rent(as % of GDP) of Nepal in 2003 to that in 2007?
Provide a succinct answer. 0.89. What is the ratio of the Rent(as % of GDP) in Samoa in 2003 to that in 2007?
Provide a short and direct response. 1.95. What is the ratio of the Rent(as % of GDP) of Guinea-Bissau in 2003 to that in 2008?
Ensure brevity in your answer.  1.11. What is the ratio of the Rent(as % of GDP) in Liberia in 2003 to that in 2008?
Offer a very short reply. 1.43. What is the ratio of the Rent(as % of GDP) of Nepal in 2003 to that in 2008?
Offer a very short reply. 1.14. What is the ratio of the Rent(as % of GDP) of Samoa in 2003 to that in 2008?
Provide a succinct answer. 1.3. What is the ratio of the Rent(as % of GDP) of Guinea-Bissau in 2003 to that in 2009?
Give a very brief answer. 1.03. What is the ratio of the Rent(as % of GDP) in Liberia in 2003 to that in 2009?
Provide a succinct answer. 1.87. What is the ratio of the Rent(as % of GDP) in Nepal in 2003 to that in 2009?
Offer a terse response. 1.25. What is the ratio of the Rent(as % of GDP) in Samoa in 2003 to that in 2009?
Make the answer very short. 1.68. What is the ratio of the Rent(as % of GDP) in Guinea-Bissau in 2004 to that in 2005?
Your response must be concise. 1.07. What is the ratio of the Rent(as % of GDP) of Liberia in 2004 to that in 2005?
Provide a succinct answer. 1.09. What is the ratio of the Rent(as % of GDP) of Nepal in 2004 to that in 2005?
Your response must be concise. 1.14. What is the ratio of the Rent(as % of GDP) in Samoa in 2004 to that in 2005?
Your answer should be very brief. 1.33. What is the ratio of the Rent(as % of GDP) of Guinea-Bissau in 2004 to that in 2006?
Ensure brevity in your answer.  1.06. What is the ratio of the Rent(as % of GDP) of Liberia in 2004 to that in 2006?
Provide a short and direct response. 1.16. What is the ratio of the Rent(as % of GDP) of Nepal in 2004 to that in 2006?
Give a very brief answer. 0.83. What is the ratio of the Rent(as % of GDP) in Samoa in 2004 to that in 2006?
Make the answer very short. 1.43. What is the ratio of the Rent(as % of GDP) of Guinea-Bissau in 2004 to that in 2007?
Provide a succinct answer. 0.85. What is the ratio of the Rent(as % of GDP) of Liberia in 2004 to that in 2007?
Give a very brief answer. 0.95. What is the ratio of the Rent(as % of GDP) in Nepal in 2004 to that in 2007?
Offer a terse response. 0.66. What is the ratio of the Rent(as % of GDP) in Samoa in 2004 to that in 2007?
Your response must be concise. 1.42. What is the ratio of the Rent(as % of GDP) in Guinea-Bissau in 2004 to that in 2008?
Offer a very short reply. 0.88. What is the ratio of the Rent(as % of GDP) of Liberia in 2004 to that in 2008?
Keep it short and to the point. 0.87. What is the ratio of the Rent(as % of GDP) in Nepal in 2004 to that in 2008?
Offer a terse response. 0.84. What is the ratio of the Rent(as % of GDP) of Samoa in 2004 to that in 2008?
Provide a succinct answer. 0.95. What is the ratio of the Rent(as % of GDP) of Guinea-Bissau in 2004 to that in 2009?
Make the answer very short. 0.82. What is the ratio of the Rent(as % of GDP) of Liberia in 2004 to that in 2009?
Your answer should be very brief. 1.13. What is the ratio of the Rent(as % of GDP) of Samoa in 2004 to that in 2009?
Offer a terse response. 1.22. What is the ratio of the Rent(as % of GDP) in Liberia in 2005 to that in 2006?
Your answer should be compact. 1.06. What is the ratio of the Rent(as % of GDP) of Nepal in 2005 to that in 2006?
Make the answer very short. 0.73. What is the ratio of the Rent(as % of GDP) in Samoa in 2005 to that in 2006?
Your answer should be compact. 1.08. What is the ratio of the Rent(as % of GDP) of Guinea-Bissau in 2005 to that in 2007?
Your response must be concise. 0.79. What is the ratio of the Rent(as % of GDP) in Liberia in 2005 to that in 2007?
Offer a very short reply. 0.87. What is the ratio of the Rent(as % of GDP) of Nepal in 2005 to that in 2007?
Ensure brevity in your answer.  0.58. What is the ratio of the Rent(as % of GDP) of Samoa in 2005 to that in 2007?
Your answer should be very brief. 1.07. What is the ratio of the Rent(as % of GDP) of Guinea-Bissau in 2005 to that in 2008?
Your answer should be very brief. 0.82. What is the ratio of the Rent(as % of GDP) of Liberia in 2005 to that in 2008?
Give a very brief answer. 0.79. What is the ratio of the Rent(as % of GDP) in Nepal in 2005 to that in 2008?
Keep it short and to the point. 0.74. What is the ratio of the Rent(as % of GDP) in Samoa in 2005 to that in 2008?
Your answer should be compact. 0.71. What is the ratio of the Rent(as % of GDP) in Guinea-Bissau in 2005 to that in 2009?
Give a very brief answer. 0.76. What is the ratio of the Rent(as % of GDP) of Liberia in 2005 to that in 2009?
Give a very brief answer. 1.04. What is the ratio of the Rent(as % of GDP) of Nepal in 2005 to that in 2009?
Your response must be concise. 0.82. What is the ratio of the Rent(as % of GDP) in Samoa in 2005 to that in 2009?
Provide a short and direct response. 0.92. What is the ratio of the Rent(as % of GDP) in Guinea-Bissau in 2006 to that in 2007?
Give a very brief answer. 0.8. What is the ratio of the Rent(as % of GDP) in Liberia in 2006 to that in 2007?
Give a very brief answer. 0.82. What is the ratio of the Rent(as % of GDP) of Nepal in 2006 to that in 2007?
Offer a terse response. 0.8. What is the ratio of the Rent(as % of GDP) of Samoa in 2006 to that in 2007?
Provide a succinct answer. 0.99. What is the ratio of the Rent(as % of GDP) of Guinea-Bissau in 2006 to that in 2008?
Keep it short and to the point. 0.83. What is the ratio of the Rent(as % of GDP) in Liberia in 2006 to that in 2008?
Offer a terse response. 0.75. What is the ratio of the Rent(as % of GDP) in Nepal in 2006 to that in 2008?
Give a very brief answer. 1.01. What is the ratio of the Rent(as % of GDP) in Samoa in 2006 to that in 2008?
Ensure brevity in your answer.  0.66. What is the ratio of the Rent(as % of GDP) in Guinea-Bissau in 2006 to that in 2009?
Your response must be concise. 0.77. What is the ratio of the Rent(as % of GDP) in Liberia in 2006 to that in 2009?
Keep it short and to the point. 0.98. What is the ratio of the Rent(as % of GDP) in Nepal in 2006 to that in 2009?
Give a very brief answer. 1.11. What is the ratio of the Rent(as % of GDP) in Samoa in 2006 to that in 2009?
Provide a succinct answer. 0.85. What is the ratio of the Rent(as % of GDP) in Guinea-Bissau in 2007 to that in 2008?
Give a very brief answer. 1.04. What is the ratio of the Rent(as % of GDP) in Liberia in 2007 to that in 2008?
Ensure brevity in your answer.  0.91. What is the ratio of the Rent(as % of GDP) of Nepal in 2007 to that in 2008?
Offer a very short reply. 1.27. What is the ratio of the Rent(as % of GDP) of Samoa in 2007 to that in 2008?
Ensure brevity in your answer.  0.67. What is the ratio of the Rent(as % of GDP) of Guinea-Bissau in 2007 to that in 2009?
Offer a terse response. 0.97. What is the ratio of the Rent(as % of GDP) of Liberia in 2007 to that in 2009?
Make the answer very short. 1.19. What is the ratio of the Rent(as % of GDP) in Nepal in 2007 to that in 2009?
Provide a short and direct response. 1.4. What is the ratio of the Rent(as % of GDP) in Samoa in 2007 to that in 2009?
Offer a terse response. 0.86. What is the ratio of the Rent(as % of GDP) in Liberia in 2008 to that in 2009?
Your answer should be very brief. 1.31. What is the ratio of the Rent(as % of GDP) of Nepal in 2008 to that in 2009?
Your response must be concise. 1.1. What is the ratio of the Rent(as % of GDP) in Samoa in 2008 to that in 2009?
Your answer should be very brief. 1.29. What is the difference between the highest and the second highest Rent(as % of GDP) in Guinea-Bissau?
Ensure brevity in your answer.  0.56. What is the difference between the highest and the second highest Rent(as % of GDP) of Liberia?
Give a very brief answer. 18.87. What is the difference between the highest and the second highest Rent(as % of GDP) in Nepal?
Keep it short and to the point. 0.71. What is the difference between the highest and the second highest Rent(as % of GDP) of Samoa?
Ensure brevity in your answer.  0.19. What is the difference between the highest and the lowest Rent(as % of GDP) of Guinea-Bissau?
Keep it short and to the point. 4.66. What is the difference between the highest and the lowest Rent(as % of GDP) in Liberia?
Ensure brevity in your answer.  30.01. What is the difference between the highest and the lowest Rent(as % of GDP) of Nepal?
Give a very brief answer. 2.81. What is the difference between the highest and the lowest Rent(as % of GDP) of Samoa?
Ensure brevity in your answer.  0.4. 